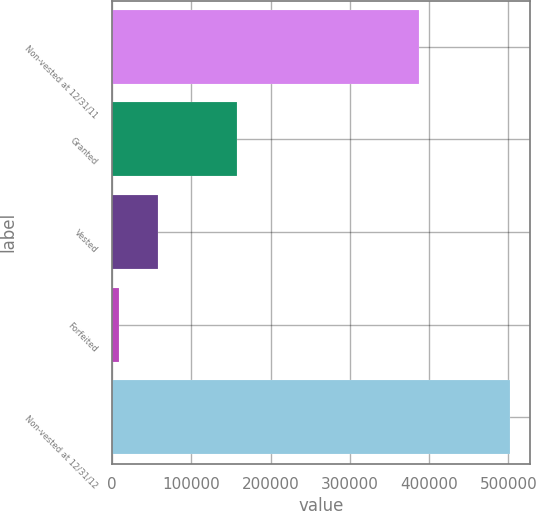Convert chart to OTSL. <chart><loc_0><loc_0><loc_500><loc_500><bar_chart><fcel>Non-vested at 12/31/11<fcel>Granted<fcel>Vested<fcel>Forfeited<fcel>Non-vested at 12/31/12<nl><fcel>387379<fcel>157348<fcel>57805.8<fcel>8373<fcel>502701<nl></chart> 